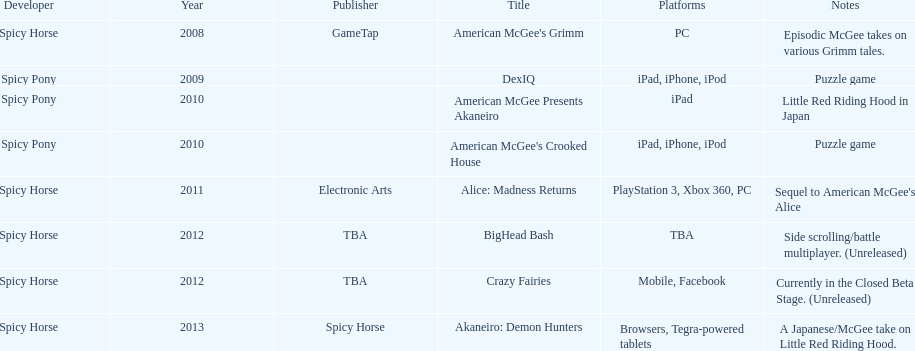What are the number of times an ipad was used as a platform? 3. 